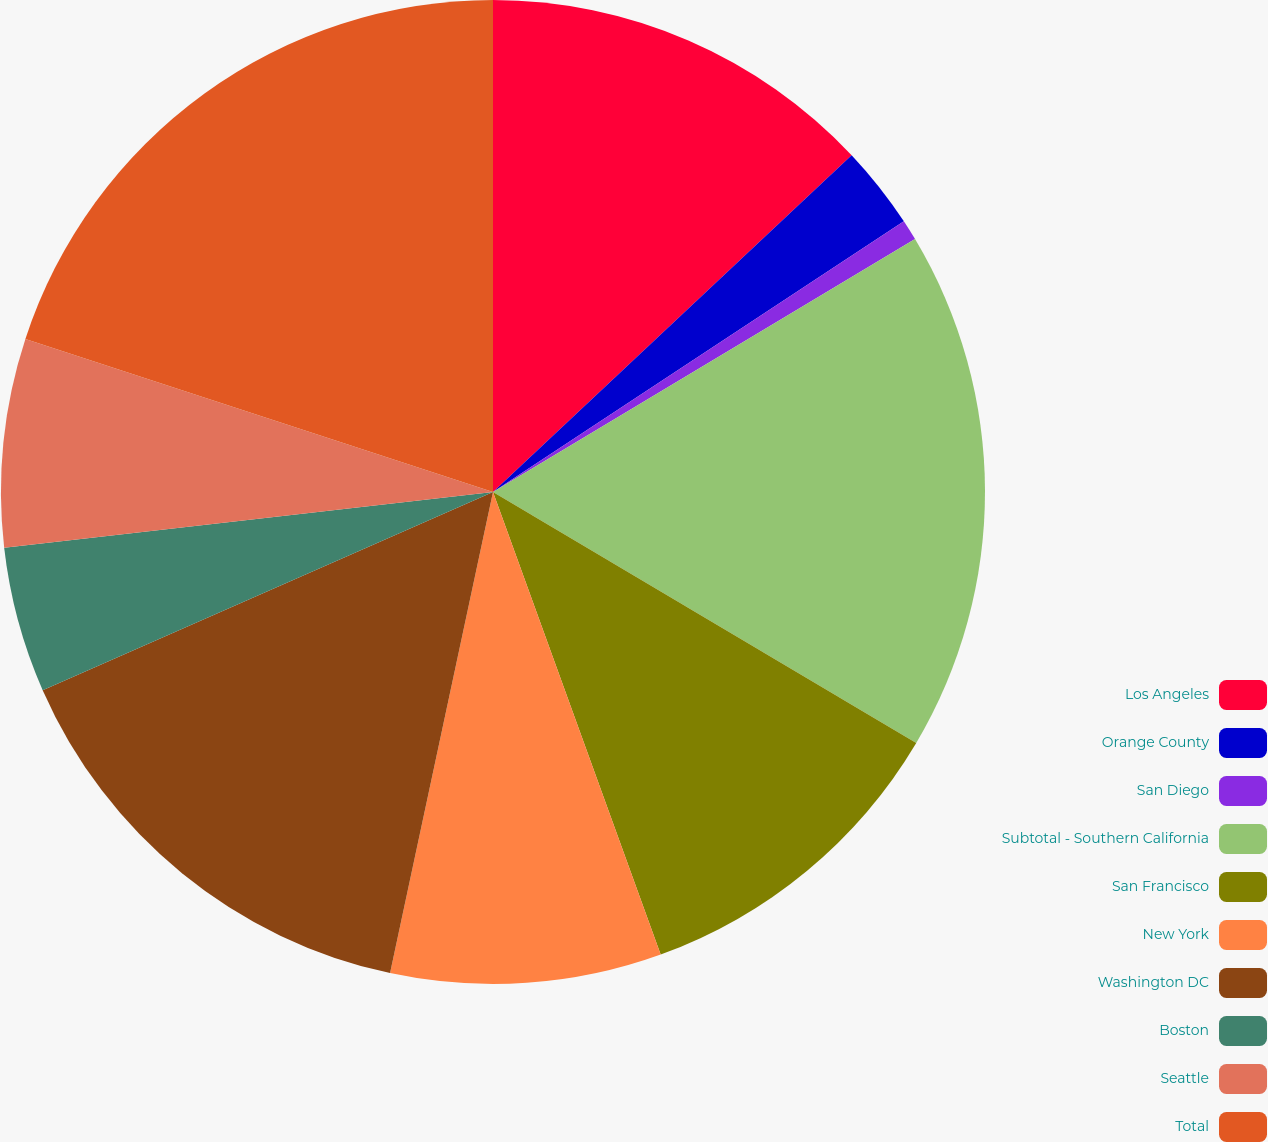Convert chart to OTSL. <chart><loc_0><loc_0><loc_500><loc_500><pie_chart><fcel>Los Angeles<fcel>Orange County<fcel>San Diego<fcel>Subtotal - Southern California<fcel>San Francisco<fcel>New York<fcel>Washington DC<fcel>Boston<fcel>Seattle<fcel>Total<nl><fcel>13.0%<fcel>2.73%<fcel>0.68%<fcel>17.11%<fcel>10.95%<fcel>8.89%<fcel>15.05%<fcel>4.79%<fcel>6.84%<fcel>19.97%<nl></chart> 